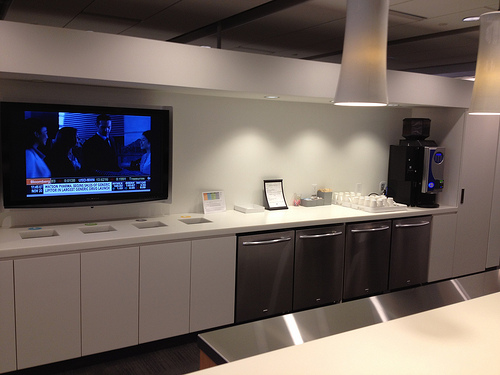Please provide the bounding box coordinate of the region this sentence describes: THE BEVERAGE MACHINE IS BLACK. The bounding box coordinates for the black beverage machine are [0.75, 0.35, 0.89, 0.55]. 